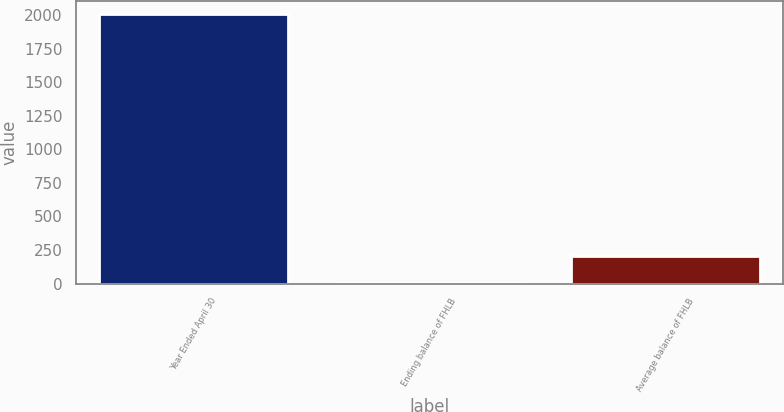Convert chart. <chart><loc_0><loc_0><loc_500><loc_500><bar_chart><fcel>Year Ended April 30<fcel>Ending balance of FHLB<fcel>Average balance of FHLB<nl><fcel>2008<fcel>2.64<fcel>203.18<nl></chart> 